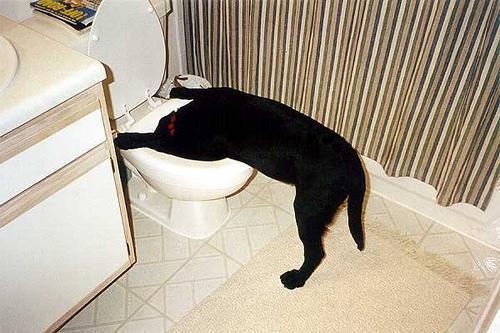How many dogs are in the picture?
Give a very brief answer. 1. How many sinks are there?
Give a very brief answer. 1. 